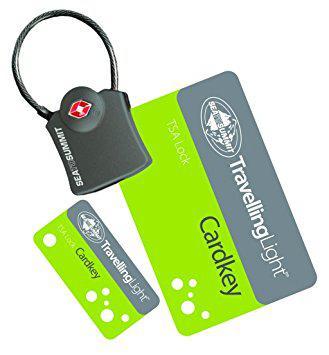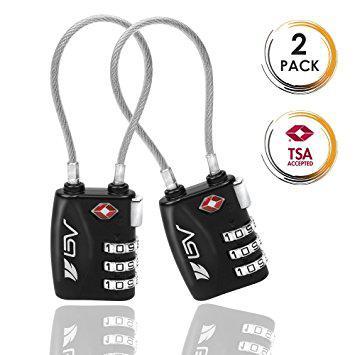The first image is the image on the left, the second image is the image on the right. Given the left and right images, does the statement "there is no more then two locks in the right side image" hold true? Answer yes or no. Yes. The first image is the image on the left, the second image is the image on the right. For the images displayed, is the sentence "One image has items other than one or more locks." factually correct? Answer yes or no. Yes. 